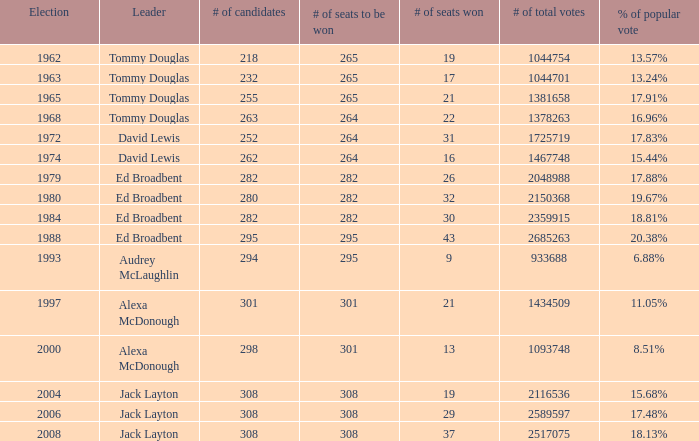Determine the amount of seats to be secured at a 295.0. 